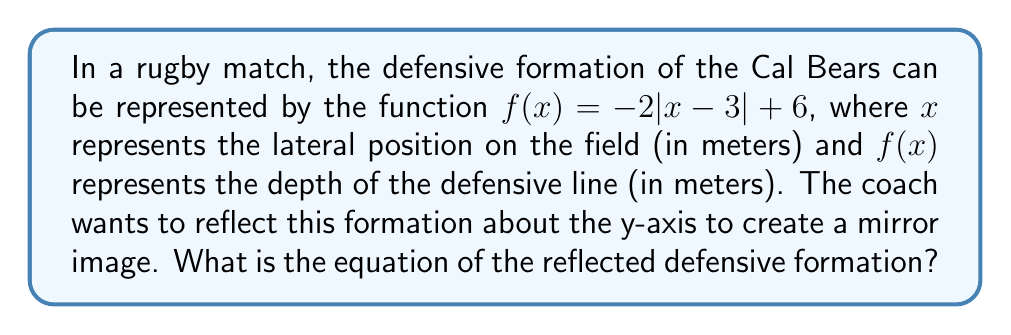Help me with this question. To reflect a function about the y-axis, we need to replace every $x$ with $-x$ in the original function. Let's go through this step-by-step:

1. Start with the original function: $f(x) = -2|x-3| + 6$

2. Replace every $x$ with $-x$:
   $g(x) = -2|(-x)-3| + 6$

3. Simplify the expression inside the absolute value brackets:
   $g(x) = -2|-x-3| + 6$

4. The negative sign can be factored out of the absolute value:
   $g(x) = -2|-1|(x+3) + 6$

5. Simplify $|-1| = 1$:
   $g(x) = -2(x+3) + 6$

6. Distribute the negative sign:
   $g(x) = -2x - 6 + 6$

7. Simplify:
   $g(x) = -2x$

Therefore, the equation of the reflected defensive formation is $g(x) = -2x$.
Answer: $g(x) = -2x$ 